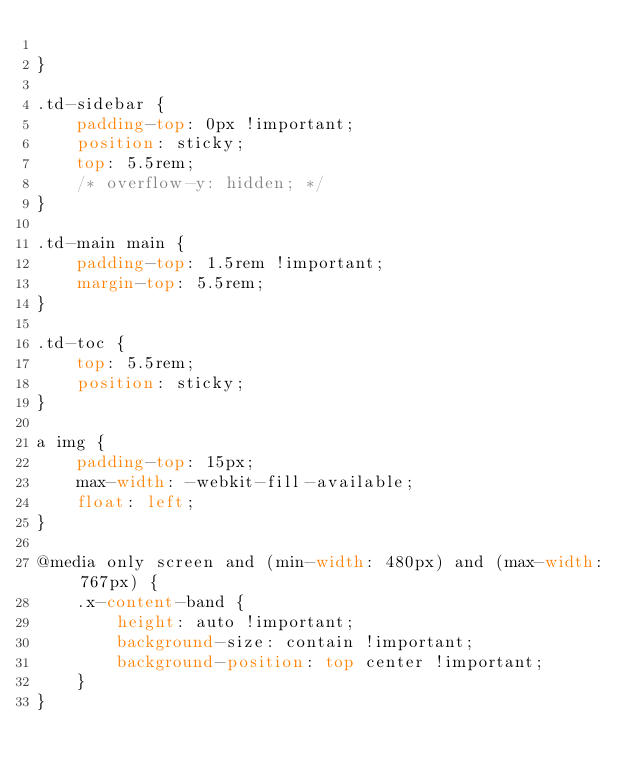Convert code to text. <code><loc_0><loc_0><loc_500><loc_500><_CSS_>
}

.td-sidebar {
    padding-top: 0px !important;
    position: sticky;
    top: 5.5rem;
    /* overflow-y: hidden; */
}

.td-main main {
    padding-top: 1.5rem !important;
    margin-top: 5.5rem;
}

.td-toc {
    top: 5.5rem;
    position: sticky;
}

a img {
    padding-top: 15px;
    max-width: -webkit-fill-available;
    float: left;
}

@media only screen and (min-width: 480px) and (max-width: 767px) {
    .x-content-band {
        height: auto !important;
        background-size: contain !important;
        background-position: top center !important;
    } 
}
</code> 